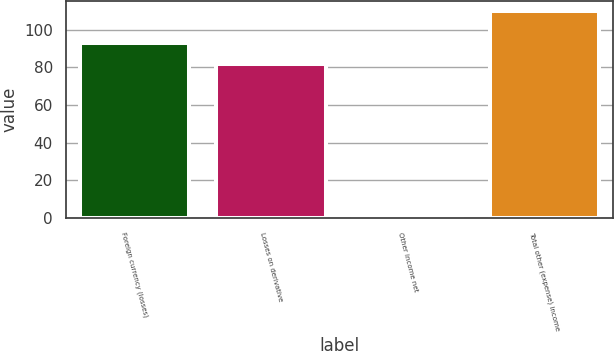Convert chart to OTSL. <chart><loc_0><loc_0><loc_500><loc_500><bar_chart><fcel>Foreign currency (losses)<fcel>Losses on derivative<fcel>Other income net<fcel>Total other (expense) income<nl><fcel>92.9<fcel>82<fcel>1<fcel>110<nl></chart> 